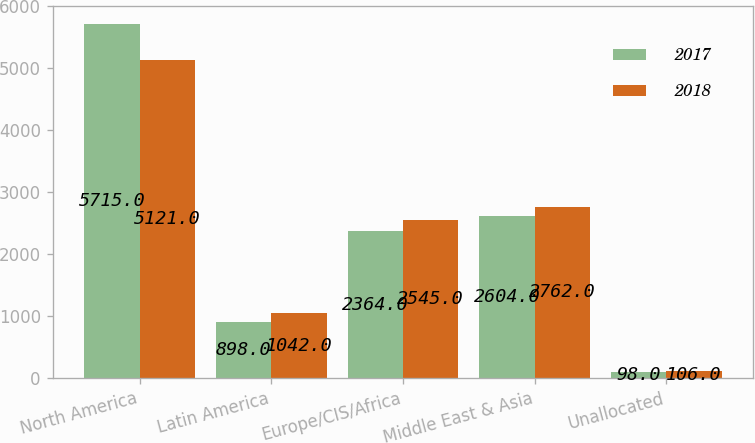Convert chart. <chart><loc_0><loc_0><loc_500><loc_500><stacked_bar_chart><ecel><fcel>North America<fcel>Latin America<fcel>Europe/CIS/Africa<fcel>Middle East & Asia<fcel>Unallocated<nl><fcel>2017<fcel>5715<fcel>898<fcel>2364<fcel>2604<fcel>98<nl><fcel>2018<fcel>5121<fcel>1042<fcel>2545<fcel>2762<fcel>106<nl></chart> 